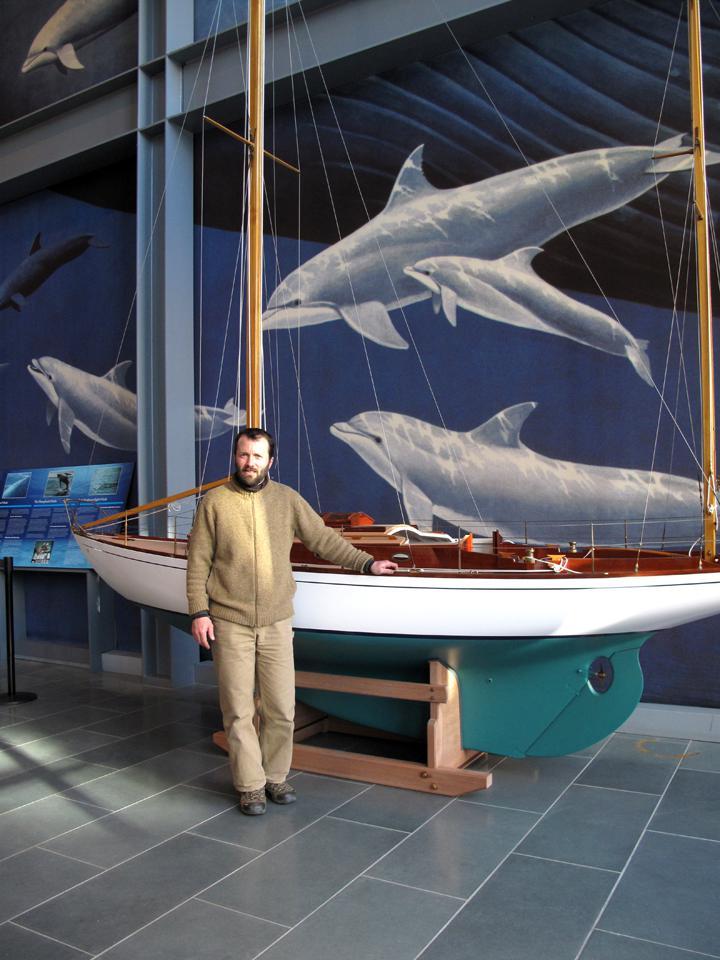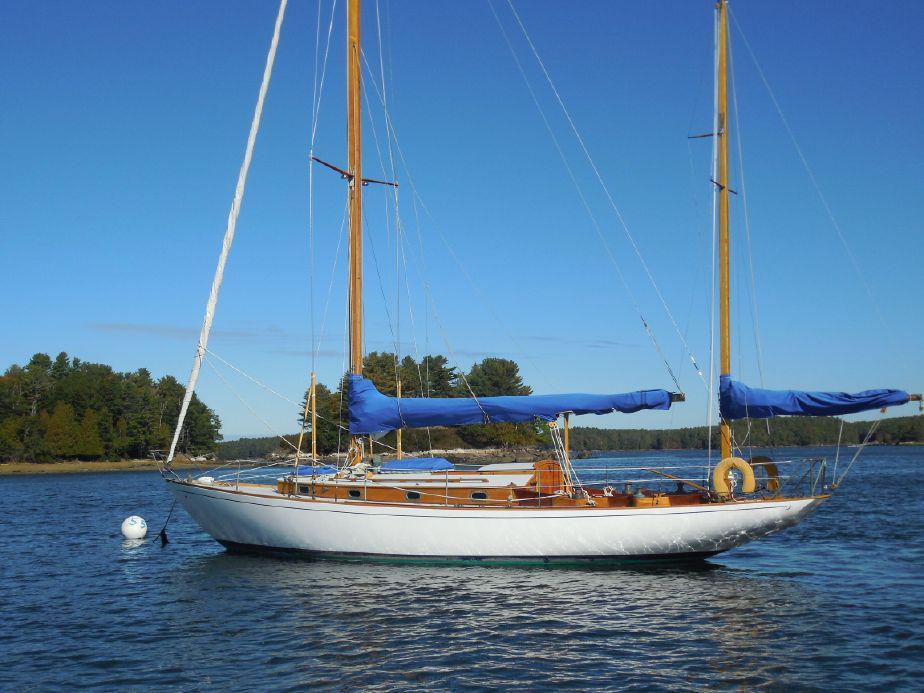The first image is the image on the left, the second image is the image on the right. For the images displayed, is the sentence "One image shows a boat that is not in a body of water." factually correct? Answer yes or no. Yes. 